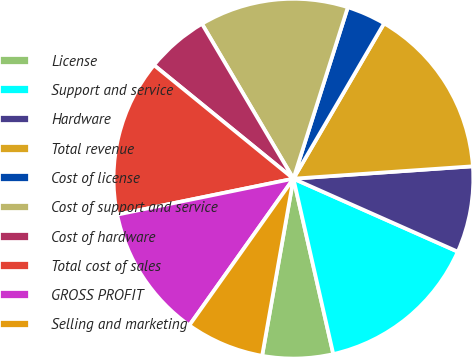Convert chart. <chart><loc_0><loc_0><loc_500><loc_500><pie_chart><fcel>License<fcel>Support and service<fcel>Hardware<fcel>Total revenue<fcel>Cost of license<fcel>Cost of support and service<fcel>Cost of hardware<fcel>Total cost of sales<fcel>GROSS PROFIT<fcel>Selling and marketing<nl><fcel>6.34%<fcel>14.79%<fcel>7.75%<fcel>15.49%<fcel>3.52%<fcel>13.38%<fcel>5.63%<fcel>14.08%<fcel>11.97%<fcel>7.04%<nl></chart> 